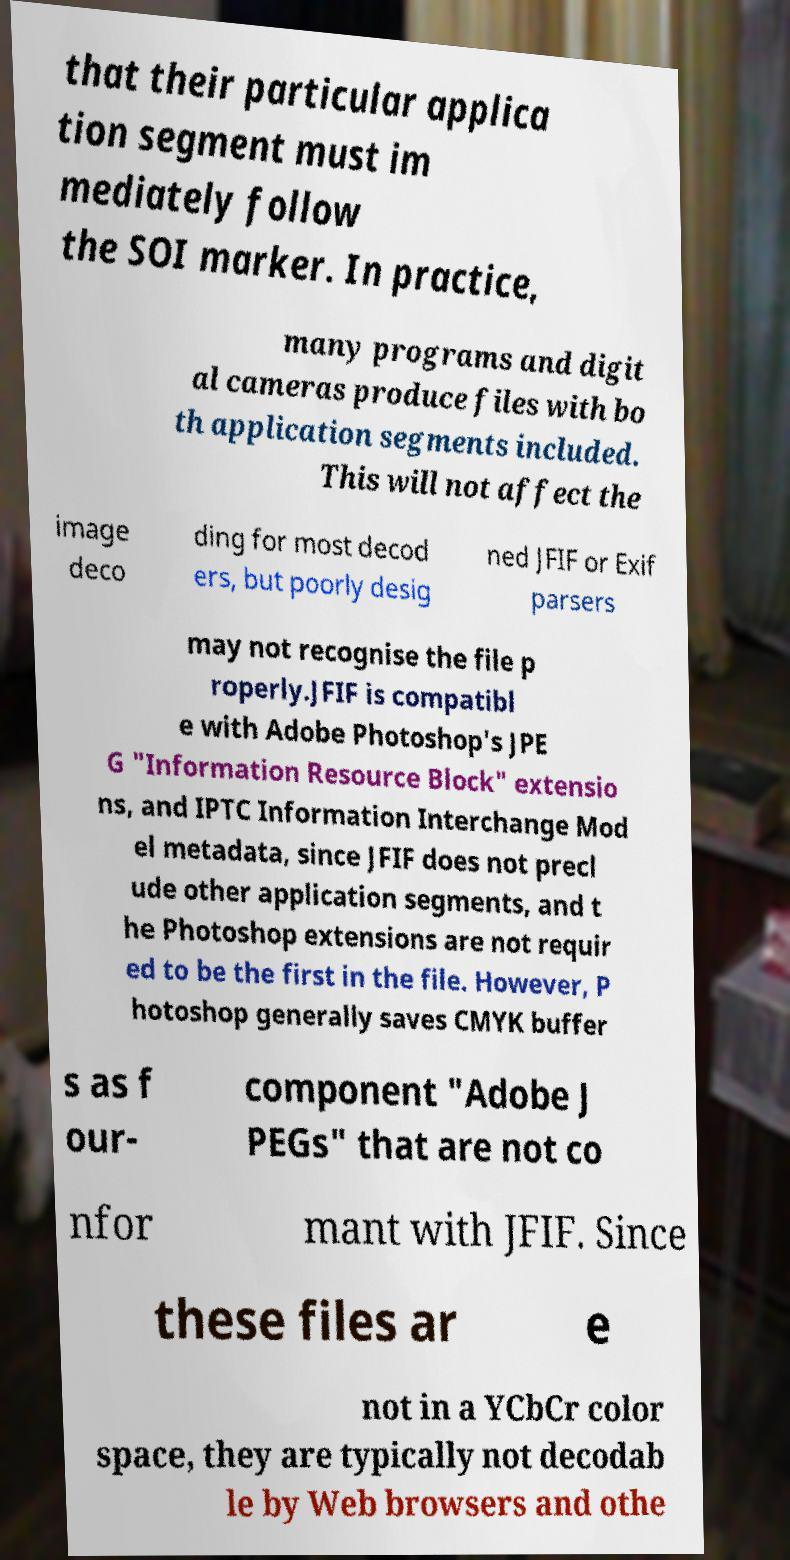What messages or text are displayed in this image? I need them in a readable, typed format. that their particular applica tion segment must im mediately follow the SOI marker. In practice, many programs and digit al cameras produce files with bo th application segments included. This will not affect the image deco ding for most decod ers, but poorly desig ned JFIF or Exif parsers may not recognise the file p roperly.JFIF is compatibl e with Adobe Photoshop's JPE G "Information Resource Block" extensio ns, and IPTC Information Interchange Mod el metadata, since JFIF does not precl ude other application segments, and t he Photoshop extensions are not requir ed to be the first in the file. However, P hotoshop generally saves CMYK buffer s as f our- component "Adobe J PEGs" that are not co nfor mant with JFIF. Since these files ar e not in a YCbCr color space, they are typically not decodab le by Web browsers and othe 